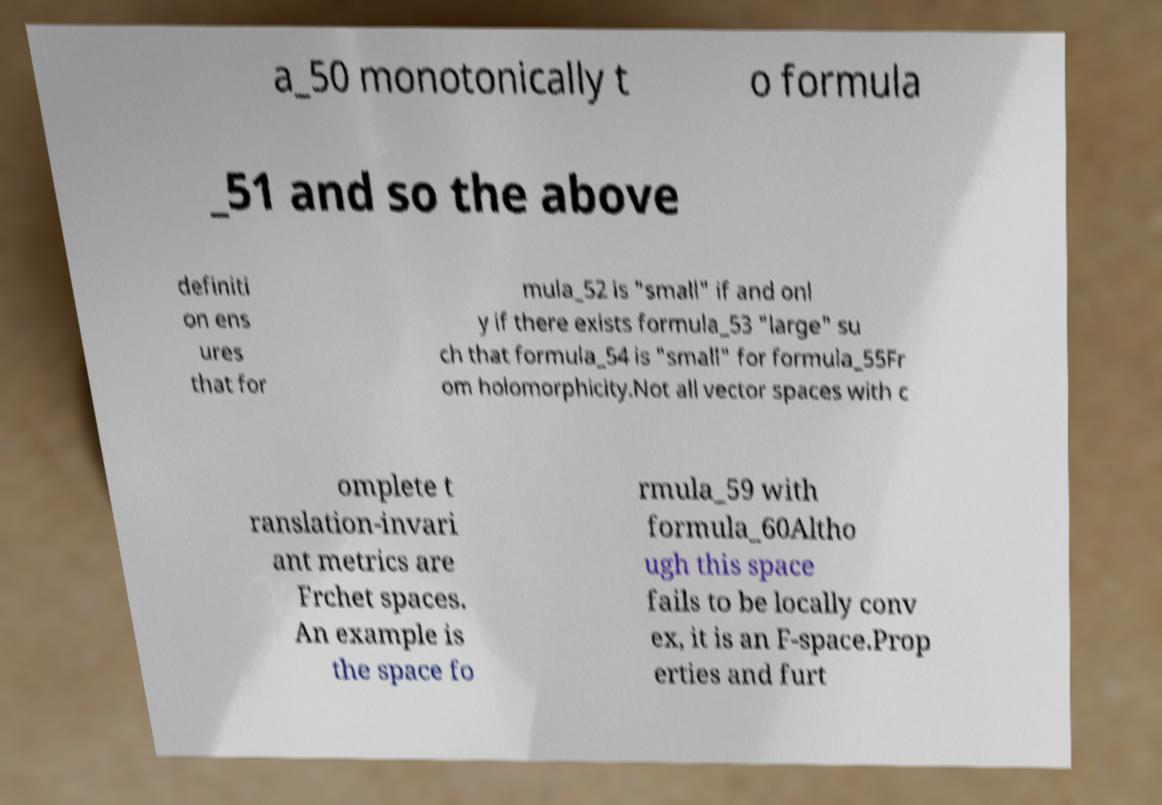There's text embedded in this image that I need extracted. Can you transcribe it verbatim? a_50 monotonically t o formula _51 and so the above definiti on ens ures that for mula_52 is "small" if and onl y if there exists formula_53 "large" su ch that formula_54 is "small" for formula_55Fr om holomorphicity.Not all vector spaces with c omplete t ranslation-invari ant metrics are Frchet spaces. An example is the space fo rmula_59 with formula_60Altho ugh this space fails to be locally conv ex, it is an F-space.Prop erties and furt 